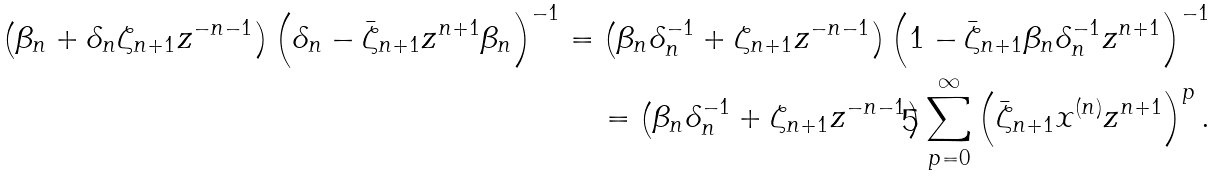<formula> <loc_0><loc_0><loc_500><loc_500>\left ( \beta _ { n } + \delta _ { n } \zeta _ { n + 1 } z ^ { - n - 1 } \right ) \left ( \delta _ { n } - \bar { \zeta } _ { n + 1 } z ^ { n + 1 } \beta _ { n } \right ) ^ { - 1 } = \left ( \beta _ { n } \delta _ { n } ^ { - 1 } + \zeta _ { n + 1 } z ^ { - n - 1 } \right ) \left ( 1 - \bar { \zeta } _ { n + 1 } \beta _ { n } \delta _ { n } ^ { - 1 } z ^ { n + 1 } \right ) ^ { - 1 } \\ = \left ( \beta _ { n } \delta _ { n } ^ { - 1 } + \zeta _ { n + 1 } z ^ { - n - 1 } \right ) \sum _ { p = 0 } ^ { \infty } \left ( \bar { \zeta } _ { n + 1 } x ^ { ( n ) } z ^ { n + 1 } \right ) ^ { p } .</formula> 